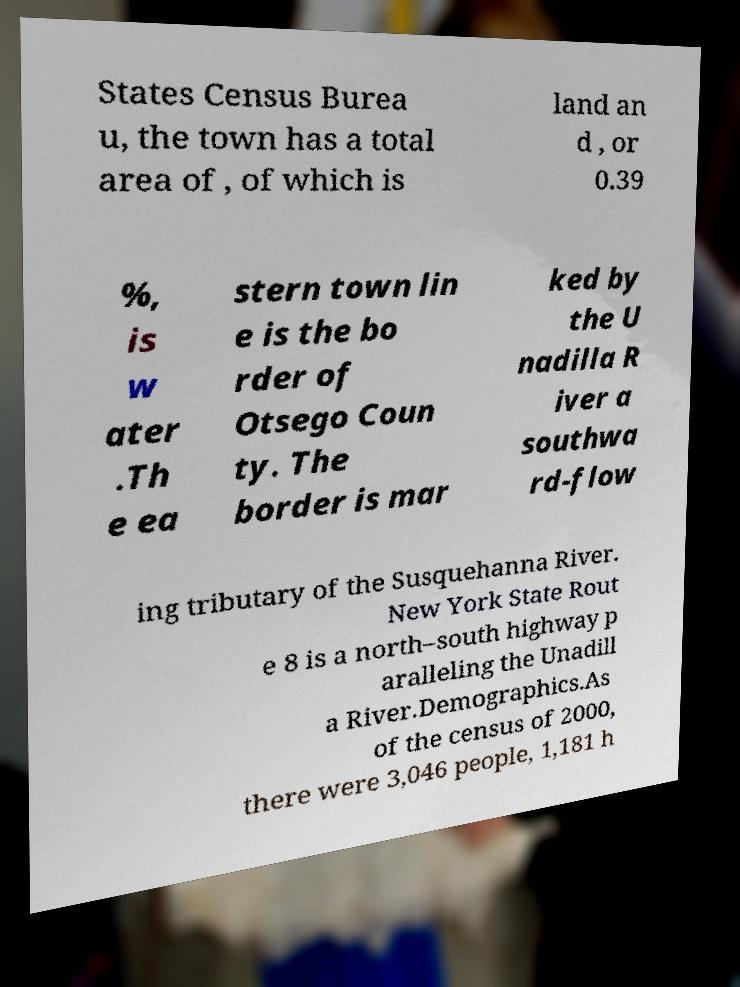Could you assist in decoding the text presented in this image and type it out clearly? States Census Burea u, the town has a total area of , of which is land an d , or 0.39 %, is w ater .Th e ea stern town lin e is the bo rder of Otsego Coun ty. The border is mar ked by the U nadilla R iver a southwa rd-flow ing tributary of the Susquehanna River. New York State Rout e 8 is a north–south highway p aralleling the Unadill a River.Demographics.As of the census of 2000, there were 3,046 people, 1,181 h 